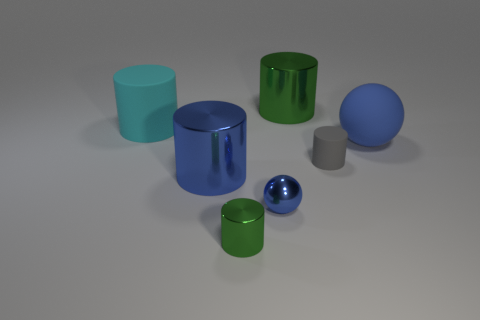There is a sphere that is in front of the gray thing; does it have the same color as the big ball?
Make the answer very short. Yes. How many other things are the same shape as the cyan object?
Your answer should be very brief. 4. There is a gray cylinder; how many large cylinders are in front of it?
Provide a succinct answer. 1. There is a cylinder that is both behind the small matte thing and to the right of the cyan cylinder; what size is it?
Make the answer very short. Large. Is there a yellow cylinder?
Your answer should be very brief. No. What number of other things are the same size as the gray thing?
Your answer should be very brief. 2. Does the big shiny cylinder behind the big blue metal cylinder have the same color as the metallic cylinder in front of the tiny blue metallic object?
Provide a succinct answer. Yes. What size is the blue metallic thing that is the same shape as the large cyan matte object?
Your answer should be very brief. Large. Is the big object that is behind the large cyan cylinder made of the same material as the green cylinder in front of the small matte thing?
Ensure brevity in your answer.  Yes. How many metallic things are either gray cylinders or cyan things?
Your answer should be compact. 0. 